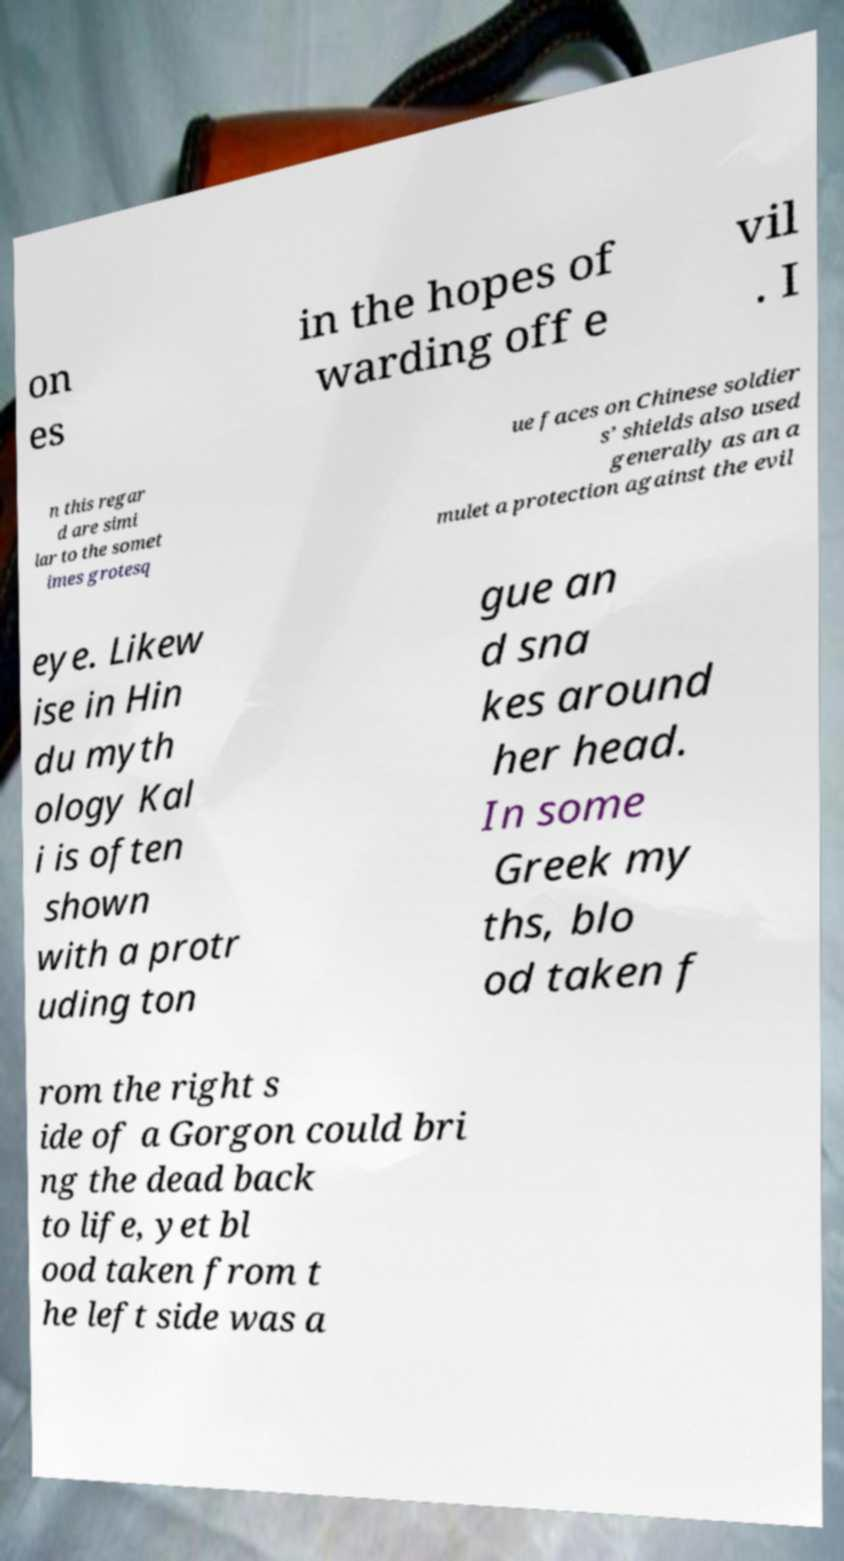What messages or text are displayed in this image? I need them in a readable, typed format. on es in the hopes of warding off e vil . I n this regar d are simi lar to the somet imes grotesq ue faces on Chinese soldier s’ shields also used generally as an a mulet a protection against the evil eye. Likew ise in Hin du myth ology Kal i is often shown with a protr uding ton gue an d sna kes around her head. In some Greek my ths, blo od taken f rom the right s ide of a Gorgon could bri ng the dead back to life, yet bl ood taken from t he left side was a 